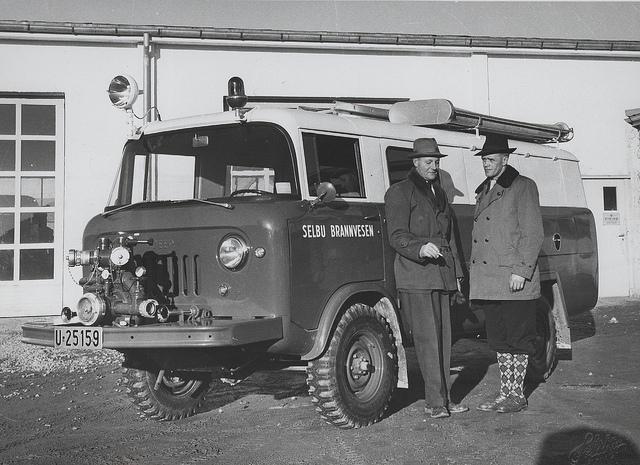How many people in the photo?
Give a very brief answer. 2. How many people are there?
Give a very brief answer. 2. How many giraffes are in this photo?
Give a very brief answer. 0. 